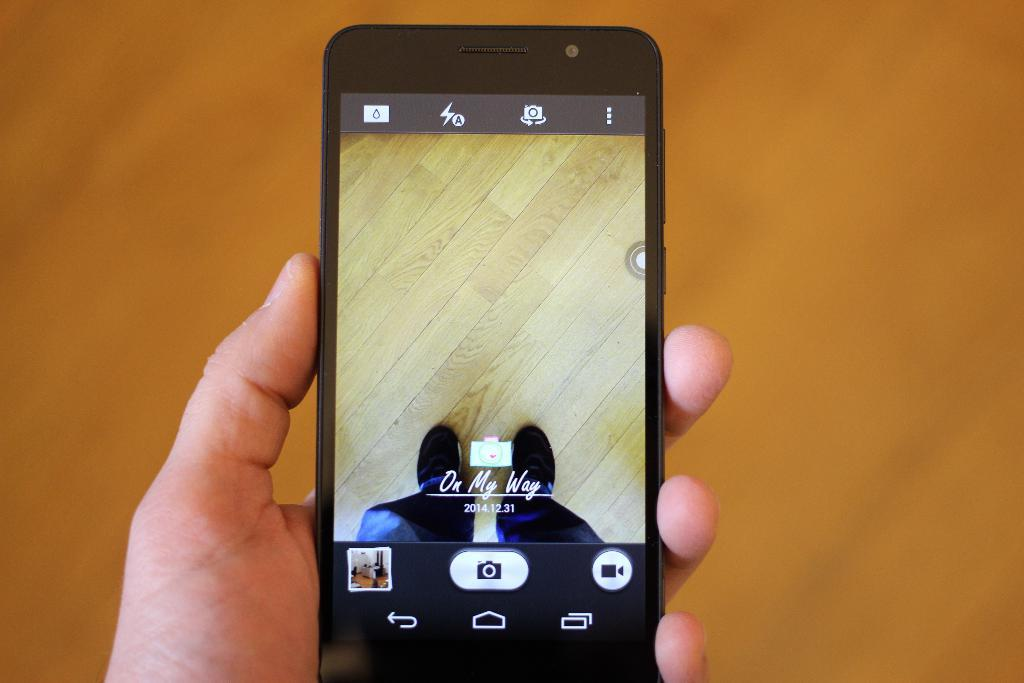Provide a one-sentence caption for the provided image. A cellphone screen shows the image of a wood floor and a pair of shoed feet with the caption "On My Way 2014.12.31.". 